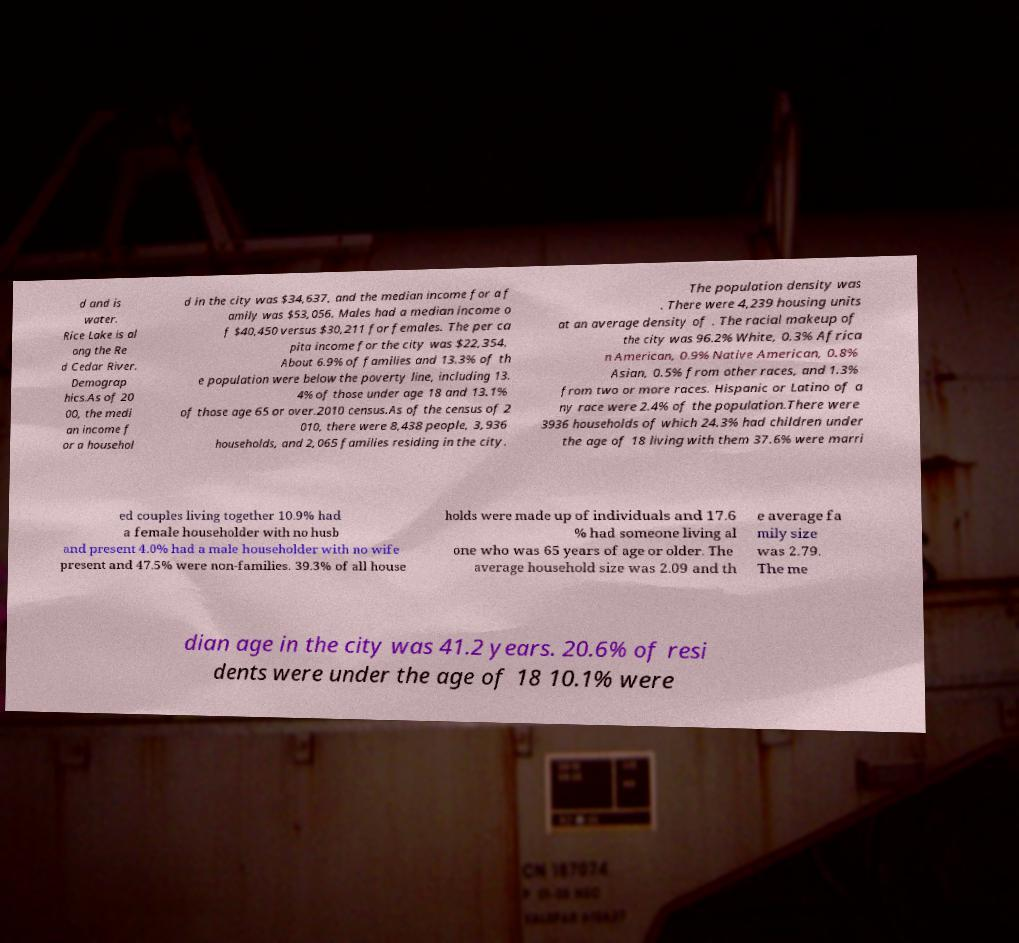For documentation purposes, I need the text within this image transcribed. Could you provide that? d and is water. Rice Lake is al ong the Re d Cedar River. Demograp hics.As of 20 00, the medi an income f or a househol d in the city was $34,637, and the median income for a f amily was $53,056. Males had a median income o f $40,450 versus $30,211 for females. The per ca pita income for the city was $22,354. About 6.9% of families and 13.3% of th e population were below the poverty line, including 13. 4% of those under age 18 and 13.1% of those age 65 or over.2010 census.As of the census of 2 010, there were 8,438 people, 3,936 households, and 2,065 families residing in the city. The population density was . There were 4,239 housing units at an average density of . The racial makeup of the city was 96.2% White, 0.3% Africa n American, 0.9% Native American, 0.8% Asian, 0.5% from other races, and 1.3% from two or more races. Hispanic or Latino of a ny race were 2.4% of the population.There were 3936 households of which 24.3% had children under the age of 18 living with them 37.6% were marri ed couples living together 10.9% had a female householder with no husb and present 4.0% had a male householder with no wife present and 47.5% were non-families. 39.3% of all house holds were made up of individuals and 17.6 % had someone living al one who was 65 years of age or older. The average household size was 2.09 and th e average fa mily size was 2.79. The me dian age in the city was 41.2 years. 20.6% of resi dents were under the age of 18 10.1% were 